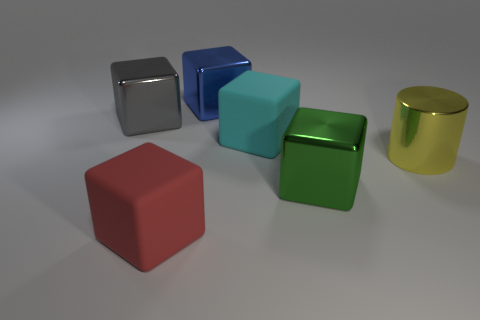What number of other things are the same shape as the cyan thing?
Your answer should be very brief. 4. Does the blue object have the same shape as the large yellow object that is behind the red matte object?
Provide a succinct answer. No. There is a cyan thing that is the same shape as the green metallic thing; what is its material?
Provide a short and direct response. Rubber. How many tiny objects are either gray cubes or brown shiny spheres?
Offer a terse response. 0. Are there fewer large yellow metal objects in front of the big red block than big blue objects that are in front of the big cyan rubber cube?
Your response must be concise. No. What number of things are green cubes or red rubber cubes?
Provide a succinct answer. 2. There is a large cyan matte cube; what number of big red matte cubes are to the right of it?
Your response must be concise. 0. What shape is the yellow thing that is the same material as the gray object?
Keep it short and to the point. Cylinder. There is a thing behind the big gray object; is it the same shape as the green metallic object?
Provide a short and direct response. Yes. How many cyan things are either tiny blocks or large blocks?
Your response must be concise. 1. 